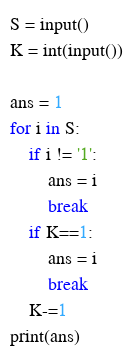Convert code to text. <code><loc_0><loc_0><loc_500><loc_500><_Python_>S = input()
K = int(input())

ans = 1
for i in S:
	if i != '1':
		ans = i
		break
	if K==1:
		ans = i
		break
	K-=1
print(ans)</code> 